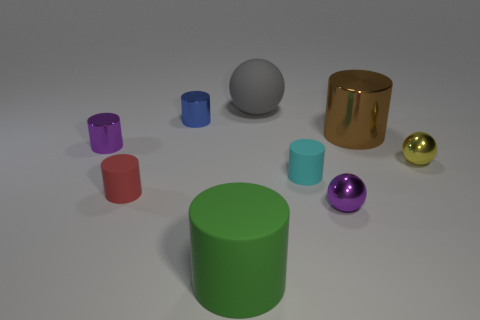There is a small blue object that is the same shape as the small red object; what is it made of?
Your answer should be very brief. Metal. What number of green rubber objects have the same size as the red matte cylinder?
Give a very brief answer. 0. There is a thing that is right of the large cylinder behind the purple object that is to the left of the large gray rubber object; what shape is it?
Keep it short and to the point. Sphere. There is a tiny metallic sphere right of the brown object; what is its color?
Give a very brief answer. Yellow. What number of things are either small shiny cylinders that are on the left side of the small red thing or tiny things right of the big gray rubber object?
Give a very brief answer. 4. How many tiny purple objects are the same shape as the big gray thing?
Your answer should be compact. 1. What color is the other rubber object that is the same size as the cyan matte object?
Your response must be concise. Red. What color is the matte thing left of the small blue cylinder that is behind the ball in front of the small cyan object?
Provide a succinct answer. Red. There is a gray rubber ball; is it the same size as the metallic cylinder that is right of the large green rubber thing?
Your response must be concise. Yes. What number of objects are big brown things or large matte objects?
Your answer should be compact. 3. 